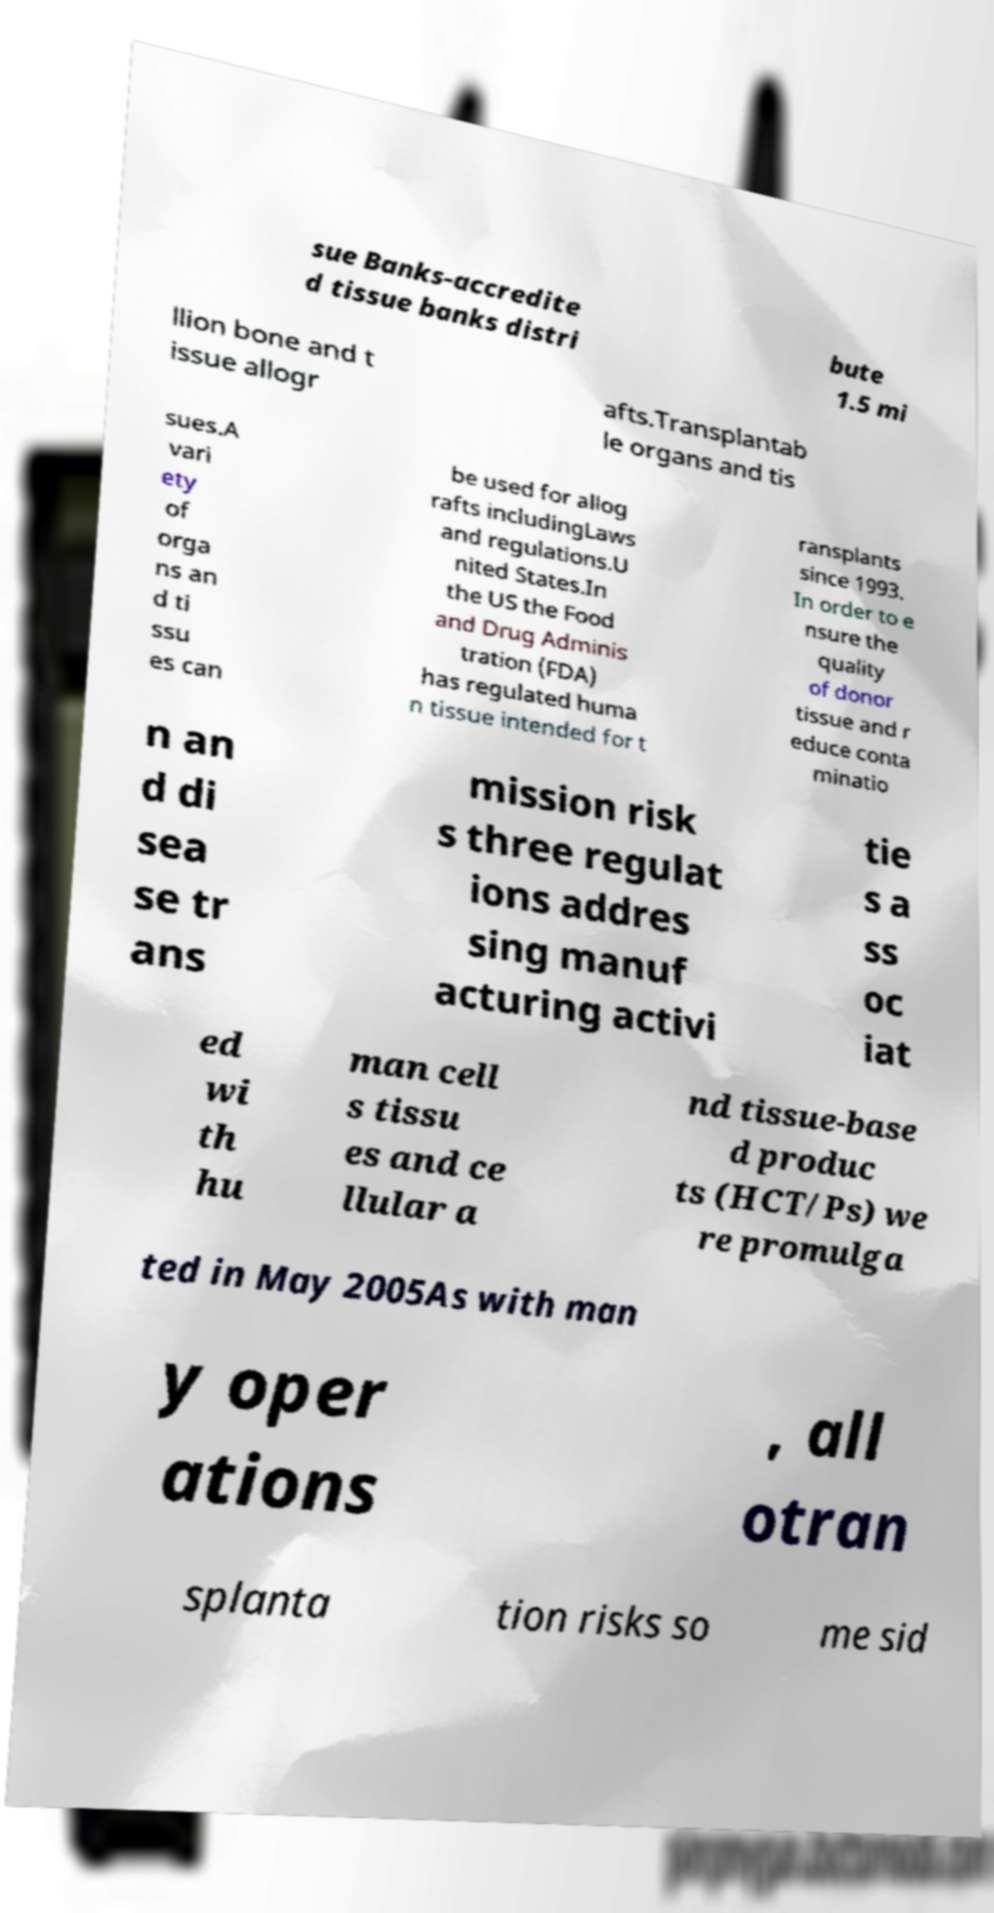Could you assist in decoding the text presented in this image and type it out clearly? sue Banks-accredite d tissue banks distri bute 1.5 mi llion bone and t issue allogr afts.Transplantab le organs and tis sues.A vari ety of orga ns an d ti ssu es can be used for allog rafts includingLaws and regulations.U nited States.In the US the Food and Drug Adminis tration (FDA) has regulated huma n tissue intended for t ransplants since 1993. In order to e nsure the quality of donor tissue and r educe conta minatio n an d di sea se tr ans mission risk s three regulat ions addres sing manuf acturing activi tie s a ss oc iat ed wi th hu man cell s tissu es and ce llular a nd tissue-base d produc ts (HCT/Ps) we re promulga ted in May 2005As with man y oper ations , all otran splanta tion risks so me sid 